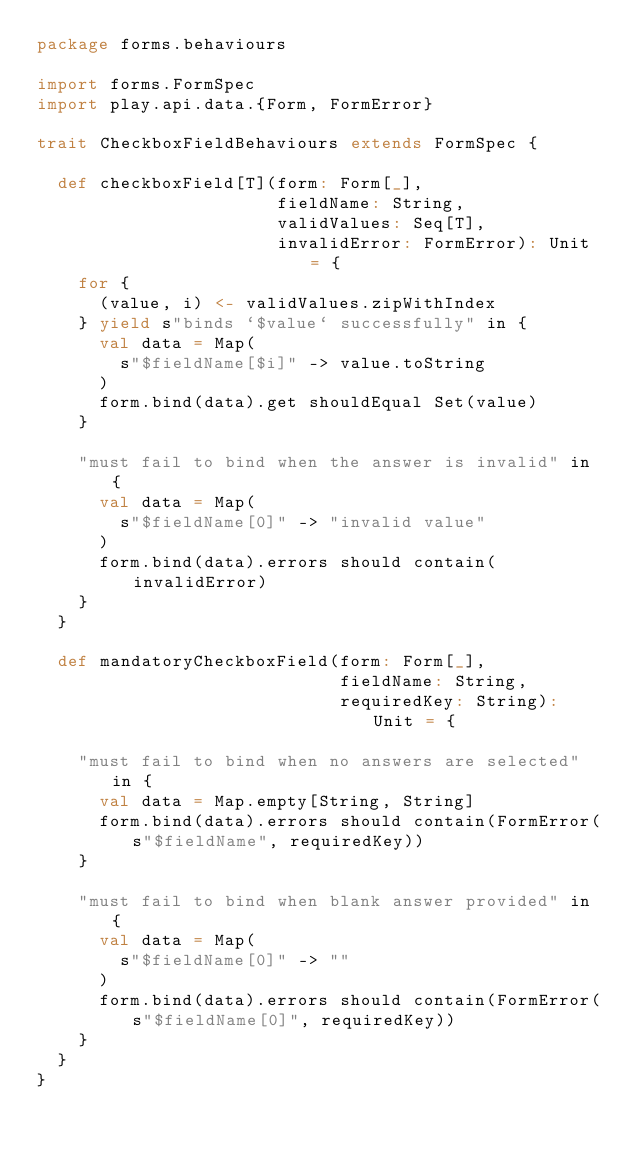Convert code to text. <code><loc_0><loc_0><loc_500><loc_500><_Scala_>package forms.behaviours

import forms.FormSpec
import play.api.data.{Form, FormError}

trait CheckboxFieldBehaviours extends FormSpec {

  def checkboxField[T](form: Form[_],
                       fieldName: String,
                       validValues: Seq[T],
                       invalidError: FormError): Unit = {
    for {
      (value, i) <- validValues.zipWithIndex
    } yield s"binds `$value` successfully" in {
      val data = Map(
        s"$fieldName[$i]" -> value.toString
      )
      form.bind(data).get shouldEqual Set(value)
    }

    "must fail to bind when the answer is invalid" in {
      val data = Map(
        s"$fieldName[0]" -> "invalid value"
      )
      form.bind(data).errors should contain(invalidError)
    }
  }

  def mandatoryCheckboxField(form: Form[_],
                             fieldName: String,
                             requiredKey: String): Unit = {

    "must fail to bind when no answers are selected" in {
      val data = Map.empty[String, String]
      form.bind(data).errors should contain(FormError(s"$fieldName", requiredKey))
    }

    "must fail to bind when blank answer provided" in {
      val data = Map(
        s"$fieldName[0]" -> ""
      )
      form.bind(data).errors should contain(FormError(s"$fieldName[0]", requiredKey))
    }
  }
}
</code> 